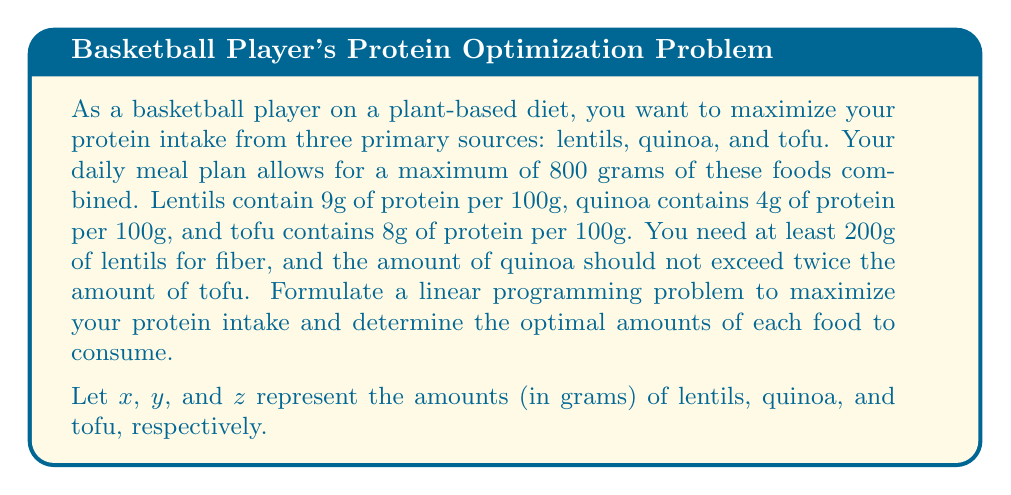Help me with this question. To solve this linear programming problem, we need to follow these steps:

1. Define the objective function:
   We want to maximize the total protein intake. The objective function is:
   $$\text{Maximize } P = 0.09x + 0.04y + 0.08z$$

2. Identify the constraints:
   a) Total food constraint: $x + y + z \leq 800$
   b) Minimum lentils constraint: $x \geq 200$
   c) Quinoa-tofu ratio constraint: $y \leq 2z$
   d) Non-negativity constraints: $x, y, z \geq 0$

3. Set up the complete linear programming problem:
   $$\begin{align*}
   \text{Maximize } & P = 0.09x + 0.04y + 0.08z \\
   \text{Subject to: } & x + y + z \leq 800 \\
   & x \geq 200 \\
   & y \leq 2z \\
   & x, y, z \geq 0
   \end{align*}$$

4. Solve the problem using the simplex method or a linear programming solver.

5. The optimal solution is:
   $x = 200$, $y = 400$, $z = 200$

6. Calculate the maximum protein intake:
   $$P = 0.09(200) + 0.04(400) + 0.08(200) = 18 + 16 + 16 = 50\text{ grams}$$
Answer: The optimal amounts to consume are 200g of lentils, 400g of quinoa, and 200g of tofu, resulting in a maximum protein intake of 50 grams. 